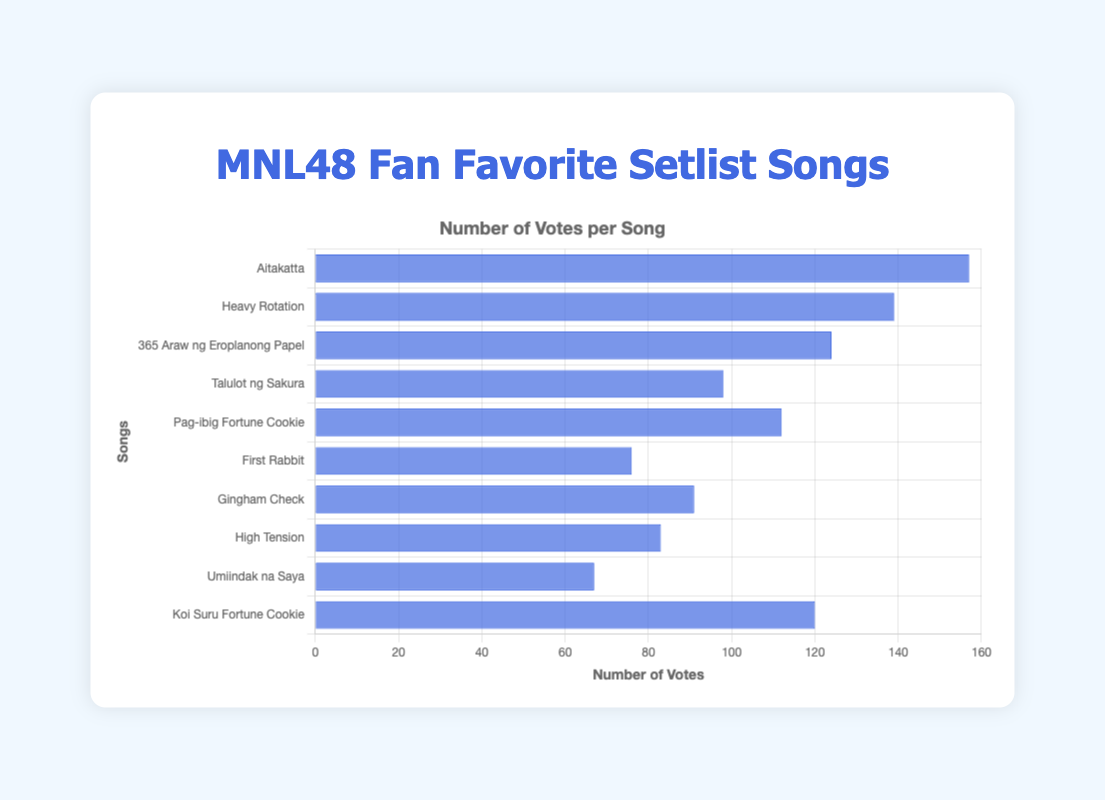What is the most preferred setlist song among MNL48 fans? The highest bar in the chart represents the most preferred setlist song based on the number of votes. "Aitakatta" has the highest number of votes (157), indicating it is the most preferred.
Answer: Aitakatta Which song has the least number of votes? The shortest bar in the chart indicates the song with the least number of votes. "Umiindak na Saya" has the fewest votes at 67.
Answer: Umiindak na Saya How many more votes does "Aitakatta" have than "First Rabbit"? Subtract the number of votes "First Rabbit" received (76) from the votes "Aitakatta" received (157). 157 - 76 = 81
Answer: 81 Which song received more votes: "Gingham Check" or "High Tension"? By comparing the heights of the bars, "Gingham Check" has 91 votes, while "High Tension" has 83 votes. Therefore, "Gingham Check" received more votes.
Answer: Gingham Check What is the sum of the votes for "Heavy Rotation" and "Pag-ibig Fortune Cookie"? Add the votes for "Heavy Rotation" (139) and "Pag-ibig Fortune Cookie" (112). 139 + 112 = 251
Answer: 251 How many songs received more than 100 votes? Count the number of bars that extend beyond the 100-vote mark: "Aitakatta", "Heavy Rotation", "365 Araw ng Eroplanong Papel", "Pag-ibig Fortune Cookie", and "Koi Suru Fortune Cookie". This gives a total of 5 songs.
Answer: 5 Which song has the closest number of votes to "365 Araw ng Eroplanong Papel"? "365 Araw ng Eroplanong Papel" received 124 votes. "Koi Suru Fortune Cookie" received 120 votes, which is the closest number to 124 among the rest of the songs.
Answer: Koi Suru Fortune Cookie What is the total number of votes for all the songs combined? Sum all the votes from each song: 157 + 139 + 124 + 98 + 112 + 76 + 91 + 83 + 67 + 120. The total is 1067 votes.
Answer: 1067 What is the average number of votes received by the songs? Divide the total number of votes by the number of songs. Total votes are 1067, and there are 10 songs: 1067 / 10 = 106.7
Answer: 106.7 Which two songs have the smallest difference in the number of votes? Calculate the differences between the votes of each pair of songs and find the smallest difference: the smallest difference is between "High Tension" (83) and "Gingham Check" (91), which is 8 votes.
Answer: High Tension and Gingham Check 